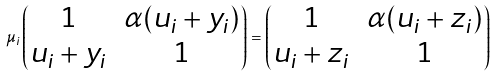<formula> <loc_0><loc_0><loc_500><loc_500>\mu _ { i } \left ( \begin{matrix} 1 & \alpha ( u _ { i } + y _ { i } ) \\ u _ { i } + y _ { i } & 1 \end{matrix} \right ) = \left ( \begin{matrix} 1 & \alpha ( u _ { i } + z _ { i } ) \\ u _ { i } + z _ { i } & 1 \end{matrix} \right )</formula> 